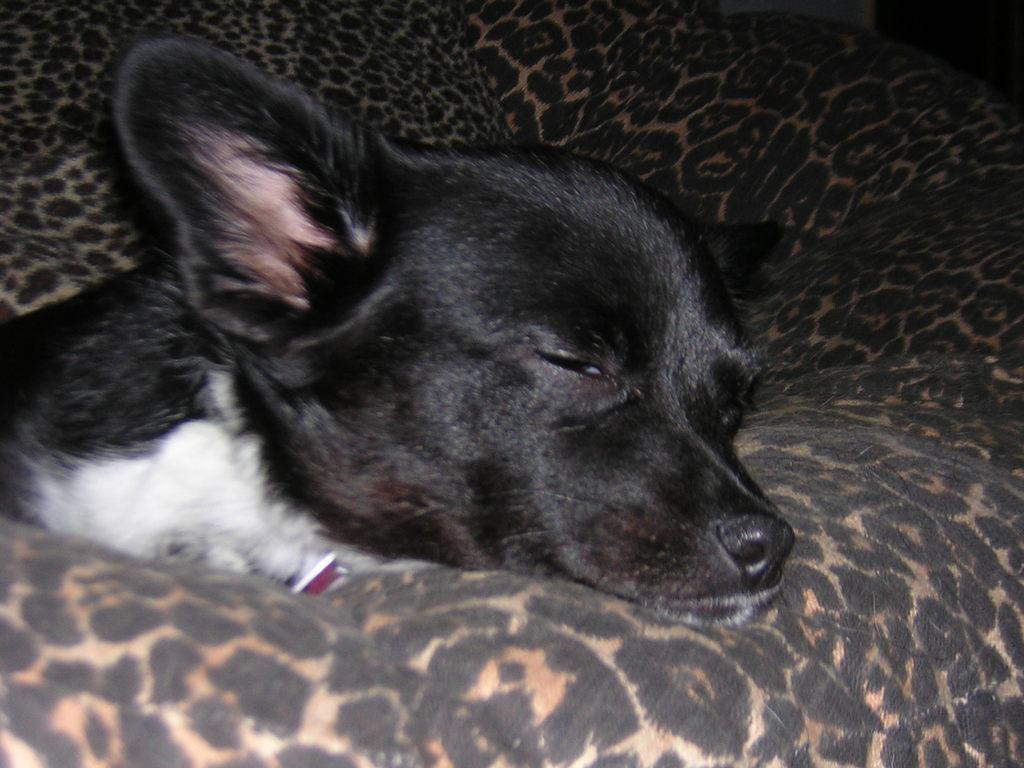What type of animal is in the image? There is a black color dog in the image. What is the dog doing in the image? The dog is sleeping. Where is the dog located in the image? The dog is on a sofa. How many giants can be seen shaking hands in the image? There are no giants or handshakes present in the image; it features a black color dog sleeping on a sofa. 